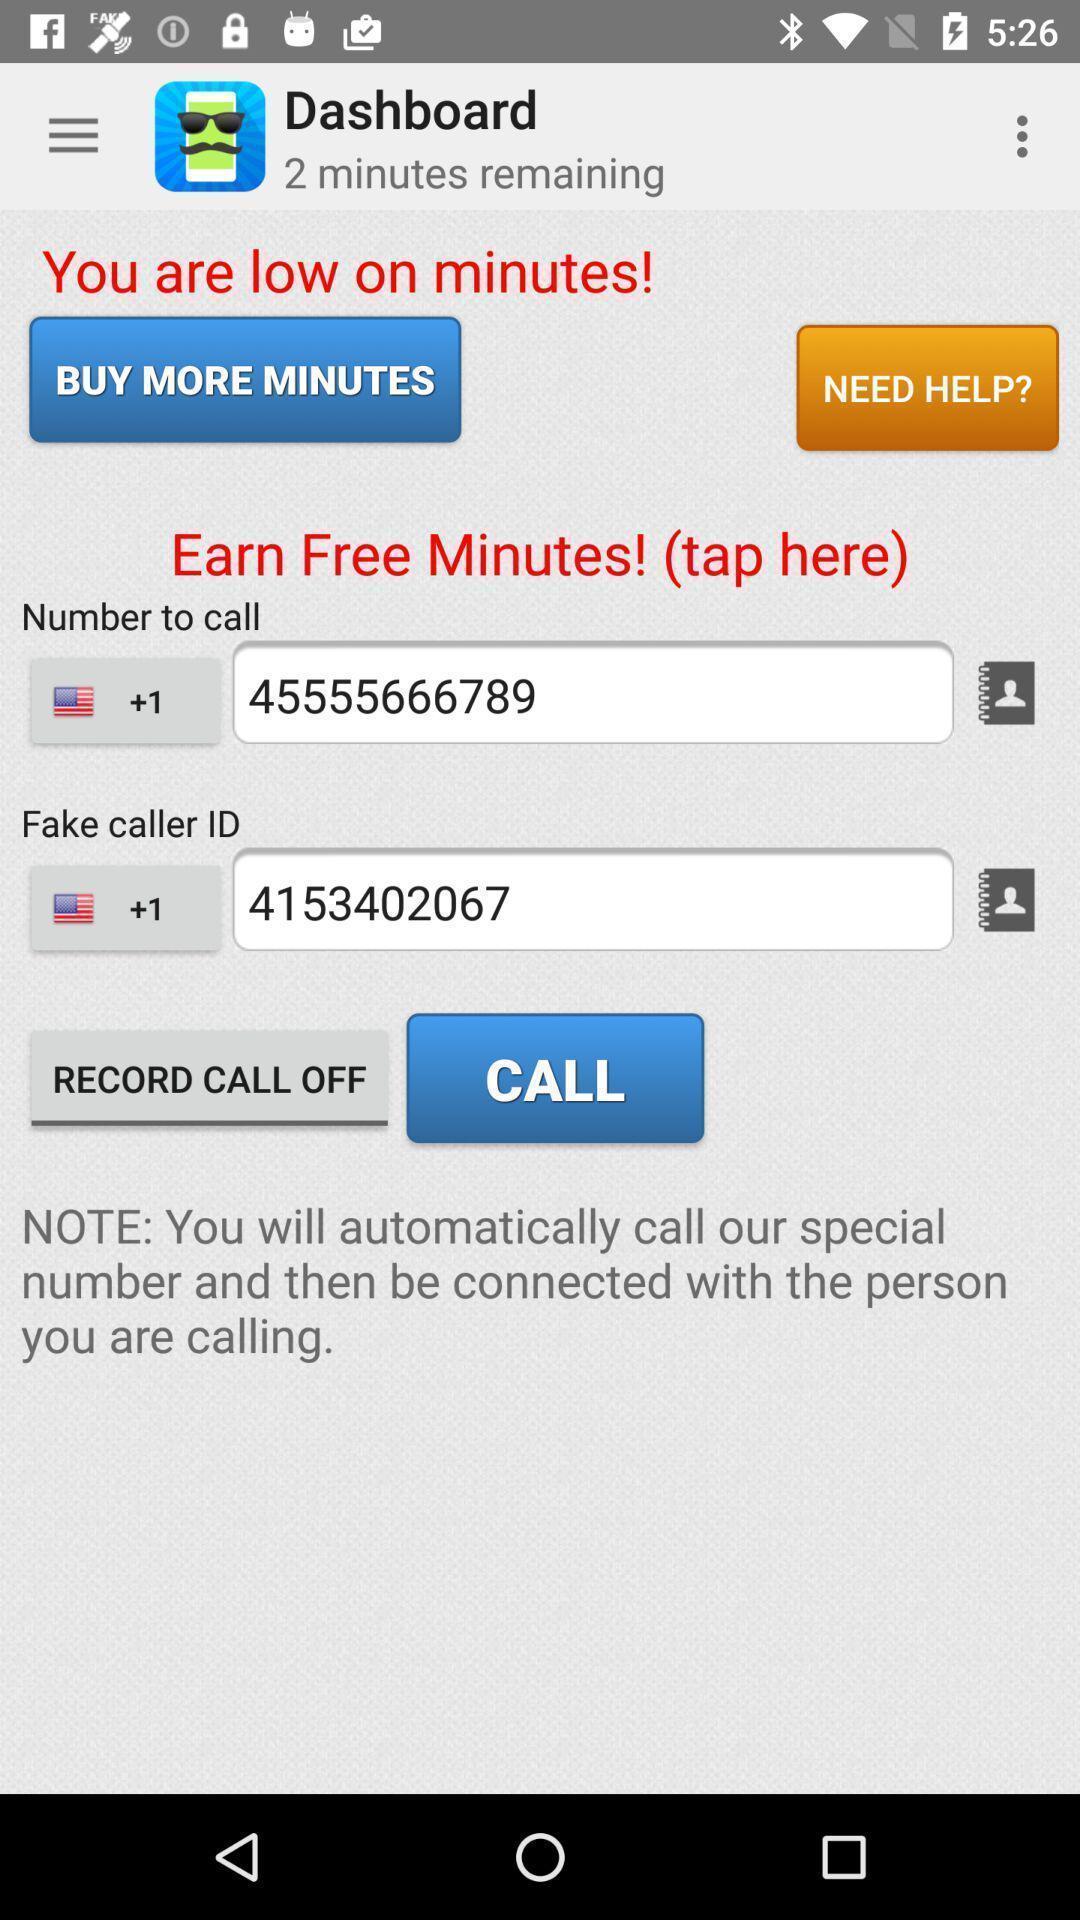Describe this image in words. Window displaying is for free minutes for call. 